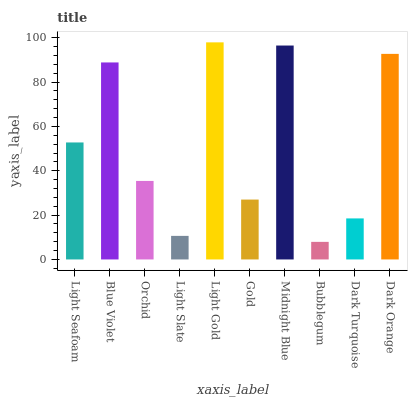Is Bubblegum the minimum?
Answer yes or no. Yes. Is Light Gold the maximum?
Answer yes or no. Yes. Is Blue Violet the minimum?
Answer yes or no. No. Is Blue Violet the maximum?
Answer yes or no. No. Is Blue Violet greater than Light Seafoam?
Answer yes or no. Yes. Is Light Seafoam less than Blue Violet?
Answer yes or no. Yes. Is Light Seafoam greater than Blue Violet?
Answer yes or no. No. Is Blue Violet less than Light Seafoam?
Answer yes or no. No. Is Light Seafoam the high median?
Answer yes or no. Yes. Is Orchid the low median?
Answer yes or no. Yes. Is Light Slate the high median?
Answer yes or no. No. Is Light Gold the low median?
Answer yes or no. No. 